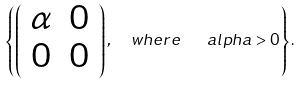<formula> <loc_0><loc_0><loc_500><loc_500>\left \{ \left ( \begin{array} { c c } \alpha & 0 \\ 0 & 0 \end{array} \right ) , \ \ w h e r e \ \ \ a l p h a > 0 \right \} .</formula> 